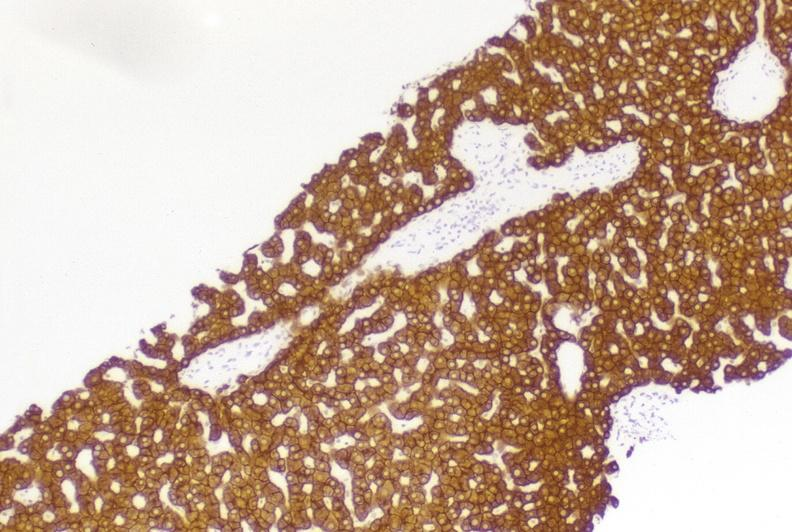does this image show high molecular weight keratin?
Answer the question using a single word or phrase. Yes 